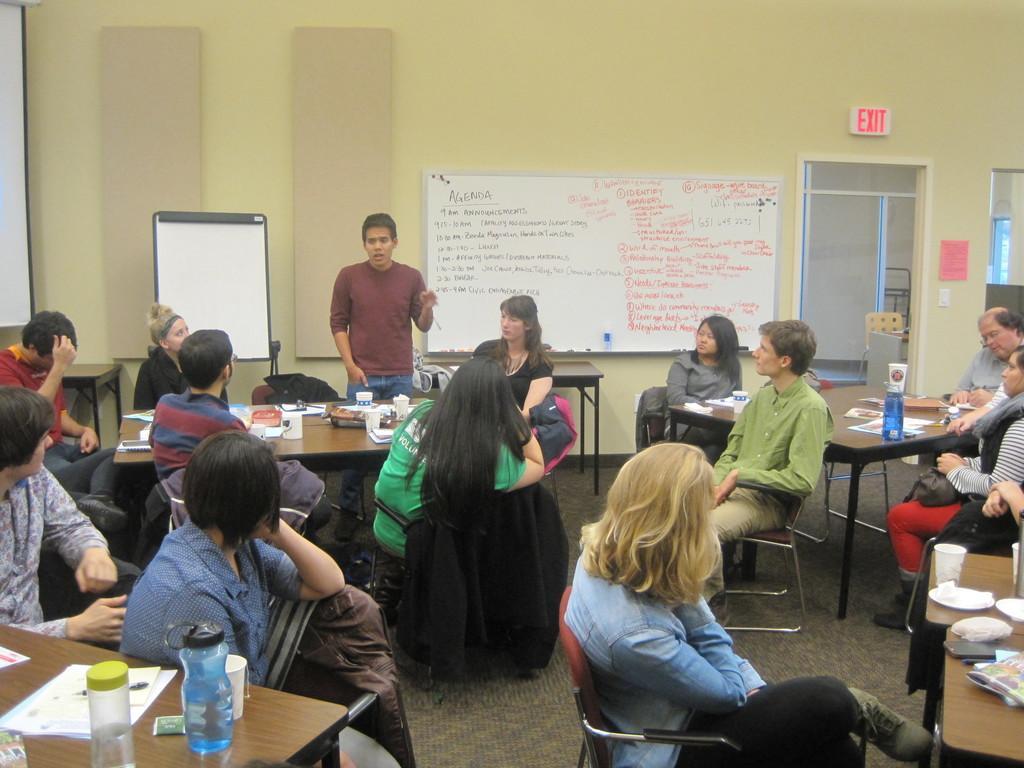In one or two sentences, can you explain what this image depicts? In this image there are tables, on that tables there are few items, around the tables there are people sitting on chairs, on man is standing, in the background there is a wall, for that wall there is a board, on that board there is some text and there is a door. 